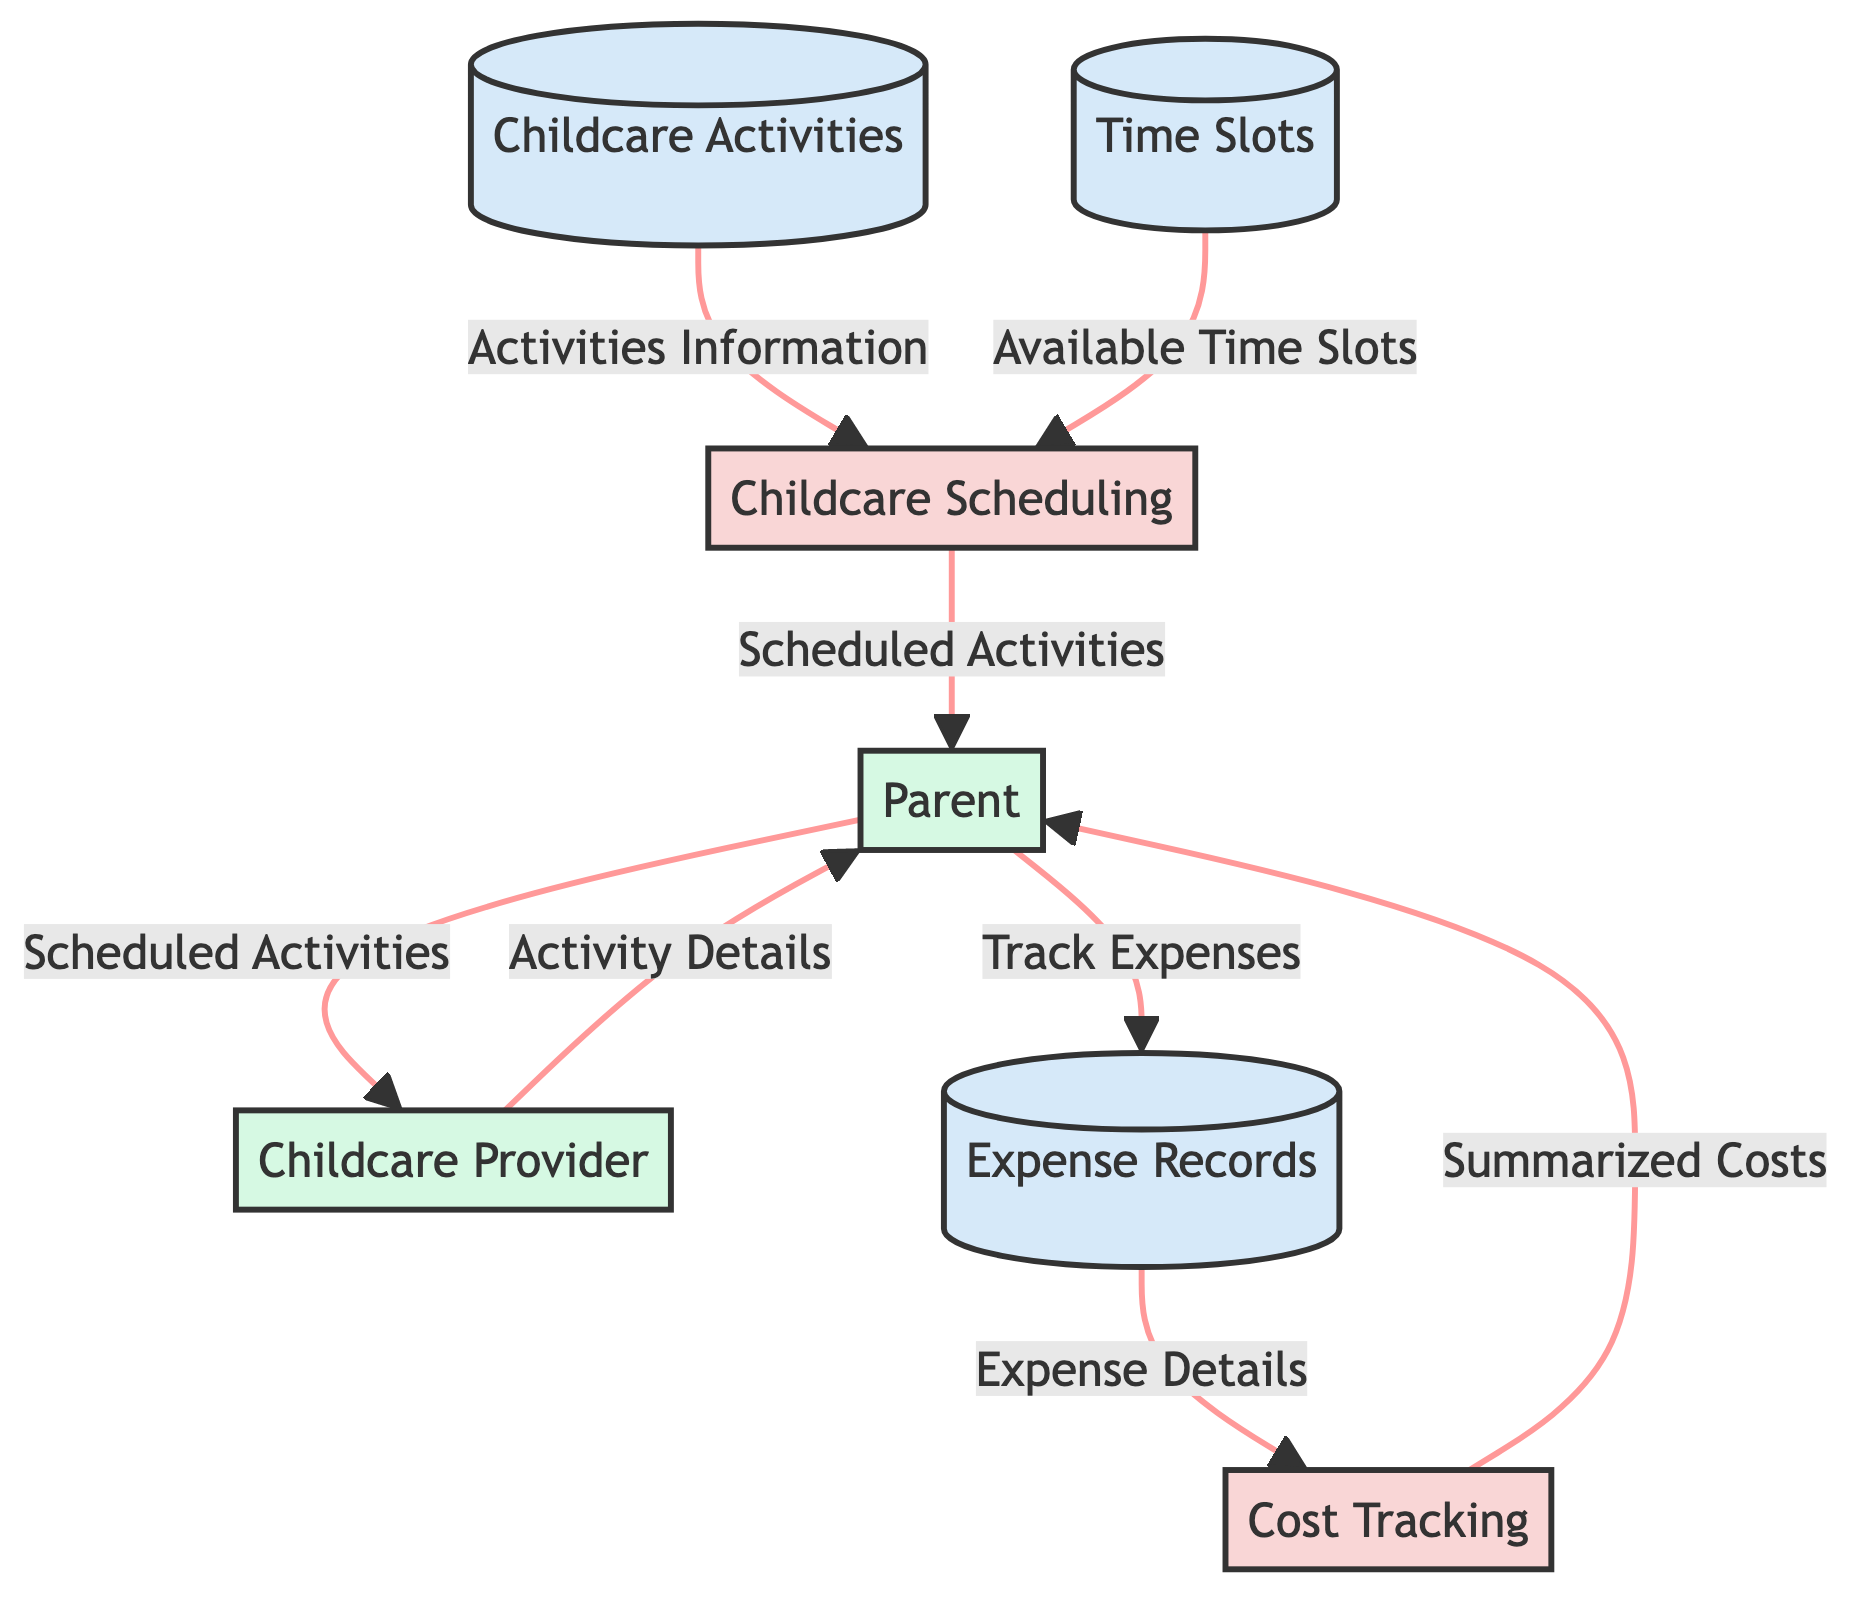What is the primary purpose of the Childcare Scheduling process? The Childcare Scheduling process is designed to manage and organize childcare activities and schedule them effectively. This can be inferred from its description directly in the diagram.
Answer: Manage and organize childcare activities and schedule How many data stores are present in the diagram? By counting the nodes labeled as data stores in the diagram, we find there are three: Childcare Activities, Time Slots, and Expense Records. Thus, the total number is three.
Answer: Three Who is the external entity that receives scheduled activities from Childcare Scheduling? The arrow in the diagram indicates that the Scheduled Activities flow from Childcare Scheduling to the Parent, identifying the Parent as the recipient of this data flow.
Answer: Parent What type of information flows from Expense Records to Cost Tracking? The diagram shows that the data flow from Expense Records to Cost Tracking refers to the details of childcare expenses, as stated in the flow description.
Answer: Details of childcare expenses Which external entity provides activity details to the Parent? The diagram illustrates that the Childcare Provider flows Activity Details to the Parent, indicating that the external entity responsible for this data flow is the Childcare Provider.
Answer: Childcare Provider What data flow is established when the Parent tracks expenses? The expense tracking process shows that the Parent sends Track Expenses data to the Expense Records, which specifically refers to documenting expenses related to childcare.
Answer: Track Expenses How many processes are depicted in the diagram? The diagram displays two distinct processes: Childcare Scheduling and Cost Tracking. By simply counting these, we can determine that there are two processes overall.
Answer: Two What information do the Time Slots provide to Childcare Scheduling? According to the diagram, the Time Slots data store supplies information regarding available time slots, which helps in the scheduling of activities.
Answer: Available time slots How does Cost Tracking communicate summarized cost information to the Parent? The diagram indicates that Cost Tracking sends Tracked Costs to the Parent, meaning that this is how summarized cost information is communicated and shared with the Parent.
Answer: Tracked Costs 